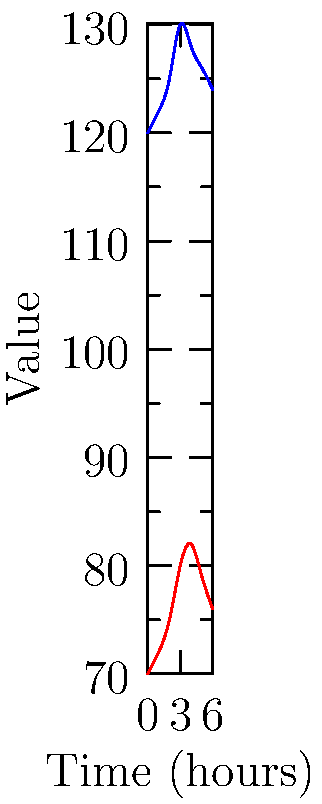A patient's vital signs are being monitored over a 6-hour period. The heart rate (in beats per minute) and systolic blood pressure (in mmHg) are recorded as vectors:

Heart Rate: $\vec{h} = \langle 70, 72, 75, 80, 82, 79, 76 \rangle$
Blood Pressure: $\vec{b} = \langle 120, 122, 125, 130, 128, 126, 124 \rangle$

Calculate the magnitude of the vector representing the change in vital signs from the initial to the final measurement. To solve this problem, we need to follow these steps:

1) First, calculate the change in each vital sign from the initial to the final measurement:

   For heart rate: $76 - 70 = 6$
   For blood pressure: $124 - 120 = 4$

2) Now we have a new vector representing the changes: $\vec{v} = \langle 6, 4 \rangle$

3) To calculate the magnitude of this vector, we use the formula:

   $\text{magnitude} = \sqrt{x^2 + y^2}$

   Where $x$ and $y$ are the components of the vector.

4) Plugging in our values:

   $\text{magnitude} = \sqrt{6^2 + 4^2}$

5) Simplify:

   $\text{magnitude} = \sqrt{36 + 16} = \sqrt{52}$

6) Simplify the square root:

   $\text{magnitude} = 2\sqrt{13}$

Therefore, the magnitude of the vector representing the change in vital signs is $2\sqrt{13}$.
Answer: $2\sqrt{13}$ 